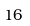Convert formula to latex. <formula><loc_0><loc_0><loc_500><loc_500>1 6</formula> 